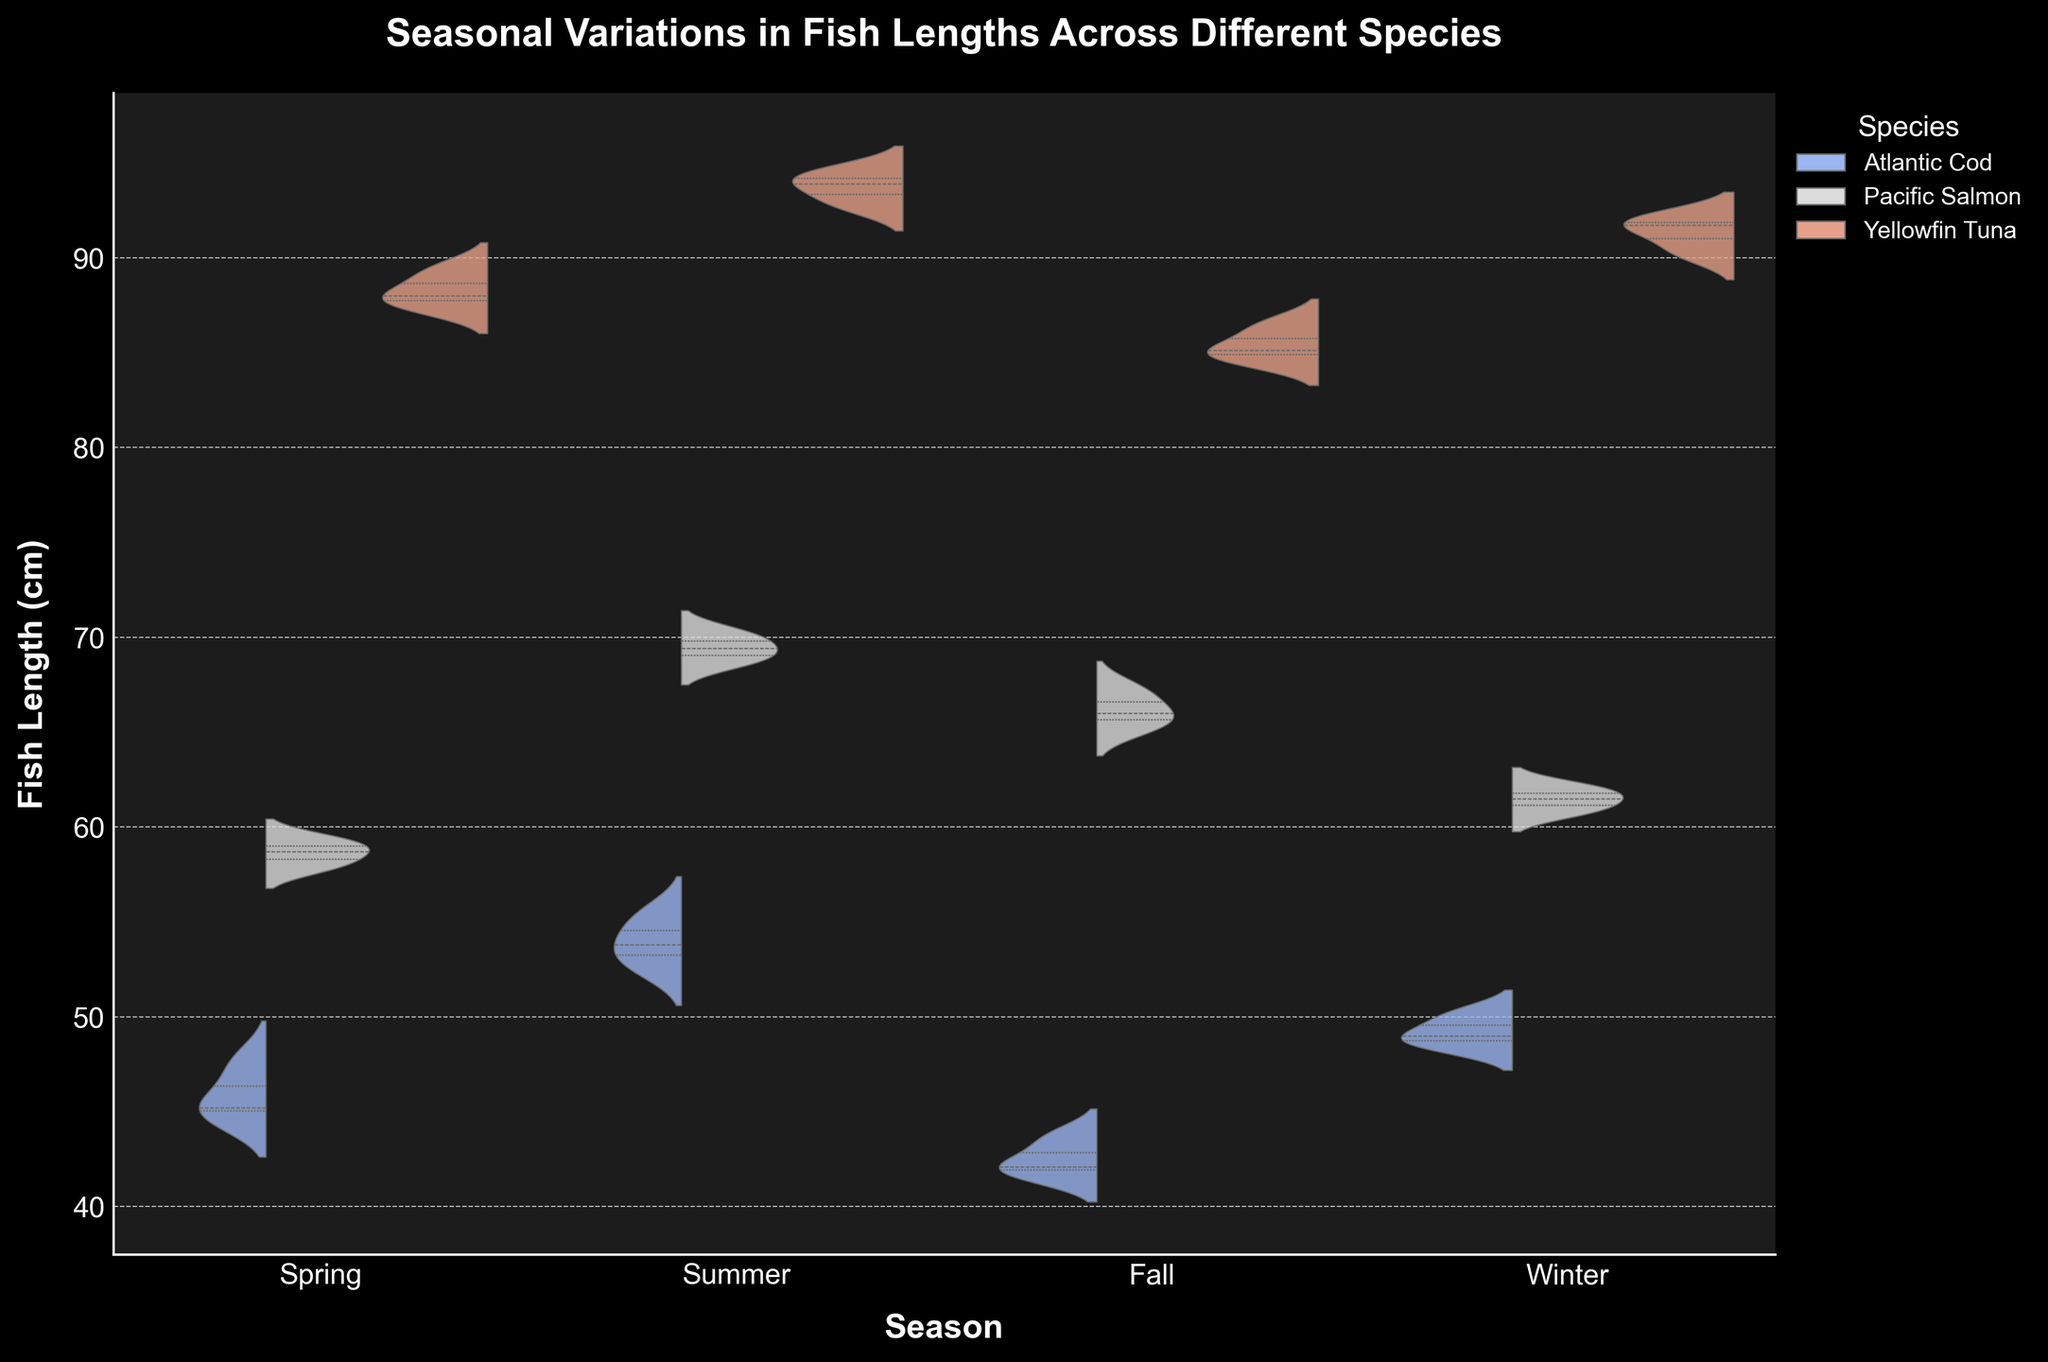What is the title of the figure? The title of a figure is typically positioned at the top, clearly stating the main focus of the visual representation. In this case, it reads "Seasonal Variations in Fish Lengths Across Different Species" which directly indicates what the figure is about.
Answer: "Seasonal Variations in Fish Lengths Across Different Species" How many unique species are compared in the figure? By looking at the legend on the right side of the figure, we can identify the number of unique species compared. Each different color represents a unique species.
Answer: 3 Which season shows the longest fish lengths for Atlantic Cod? Observing the violin plots for Atlantic Cod across all seasons (Spring, Summer, Fall, Winter), the plot with the highest median and spread indicates the longest fish lengths. For Atlantic Cod, it is the Summer season where the plot is the highest.
Answer: Summer Compare the fish lengths of Yellowfin Tuna in Spring and Summer. Which season shows greater fish lengths? Viewing the violin plots for Yellowfin Tuna, we can see the median and spread of lengths. In Spring vs. Summer, the violin plot for Summer is taller and higher on the y-axis than Spring, indicating greater lengths in Summer.
Answer: Summer Which species has the greatest range in fish lengths during Fall? By examining the vertical spread (the range) of the violin plots during the Fall season, we can determine the species with the largest range. Yellowfin Tuna shows the most extended plot, indicating the greatest range.
Answer: Yellowfin Tuna What is the approximate median length for Pacific Salmon in Winter? To find the median, look for the middle line inside the violin plot for Pacific Salmon in Winter. The median is represented by the line splitting the plot, approximately around the 61 mark.
Answer: Around 61 cm Do any species show a decreasing trend in fish length from Summer to Winter? Observing the central tendency and the overall height of the violin plots for each species from Summer to Winter, we can find that both Pacific Salmon and Yellowfin Tuna show a decrease in fish length from Summer to Winter.
Answer: Pacific Salmon and Yellowfin Tuna Which species exhibits the smallest variation in fish lengths during Spring? Variation is indicated by the spread of the violin plot. The smaller the spread, the less variation. For Spring, Atlantic Cod shows the smallest variation in the spread compared to Pacific Salmon and Yellowfin Tuna.
Answer: Atlantic Cod Are there any species where lengths decrease from Spring to Fall? By comparing the median lines and the overall height of the violin plots for each species from Spring to Fall, we can see that Atlantic Cod shows a decrease in fish lengths from Spring to Fall.
Answer: Atlantic Cod 